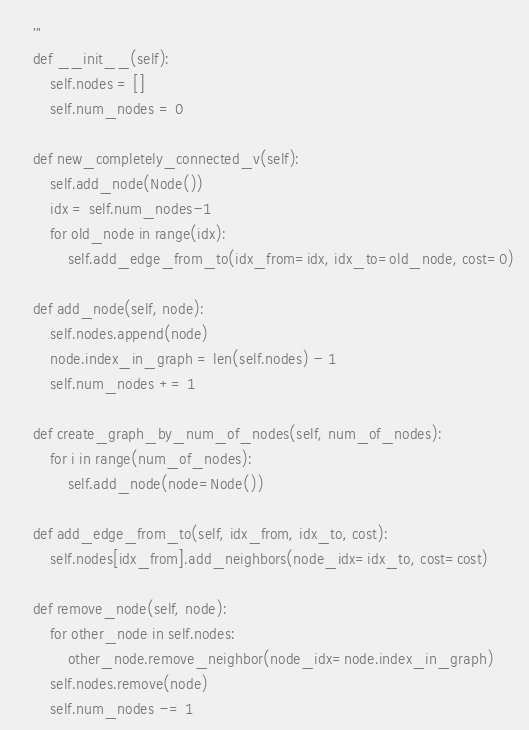<code> <loc_0><loc_0><loc_500><loc_500><_Python_>    '''
    def __init__(self):
        self.nodes = []
        self.num_nodes = 0

    def new_completely_connected_v(self):
        self.add_node(Node())
        idx = self.num_nodes-1
        for old_node in range(idx):
            self.add_edge_from_to(idx_from=idx, idx_to=old_node, cost=0)

    def add_node(self, node):
        self.nodes.append(node)
        node.index_in_graph = len(self.nodes) - 1
        self.num_nodes += 1

    def create_graph_by_num_of_nodes(self, num_of_nodes):
        for i in range(num_of_nodes):
            self.add_node(node=Node())

    def add_edge_from_to(self, idx_from, idx_to, cost):
        self.nodes[idx_from].add_neighbors(node_idx=idx_to, cost=cost)

    def remove_node(self, node):
        for other_node in self.nodes:
            other_node.remove_neighbor(node_idx=node.index_in_graph)
        self.nodes.remove(node)
        self.num_nodes -= 1
</code> 